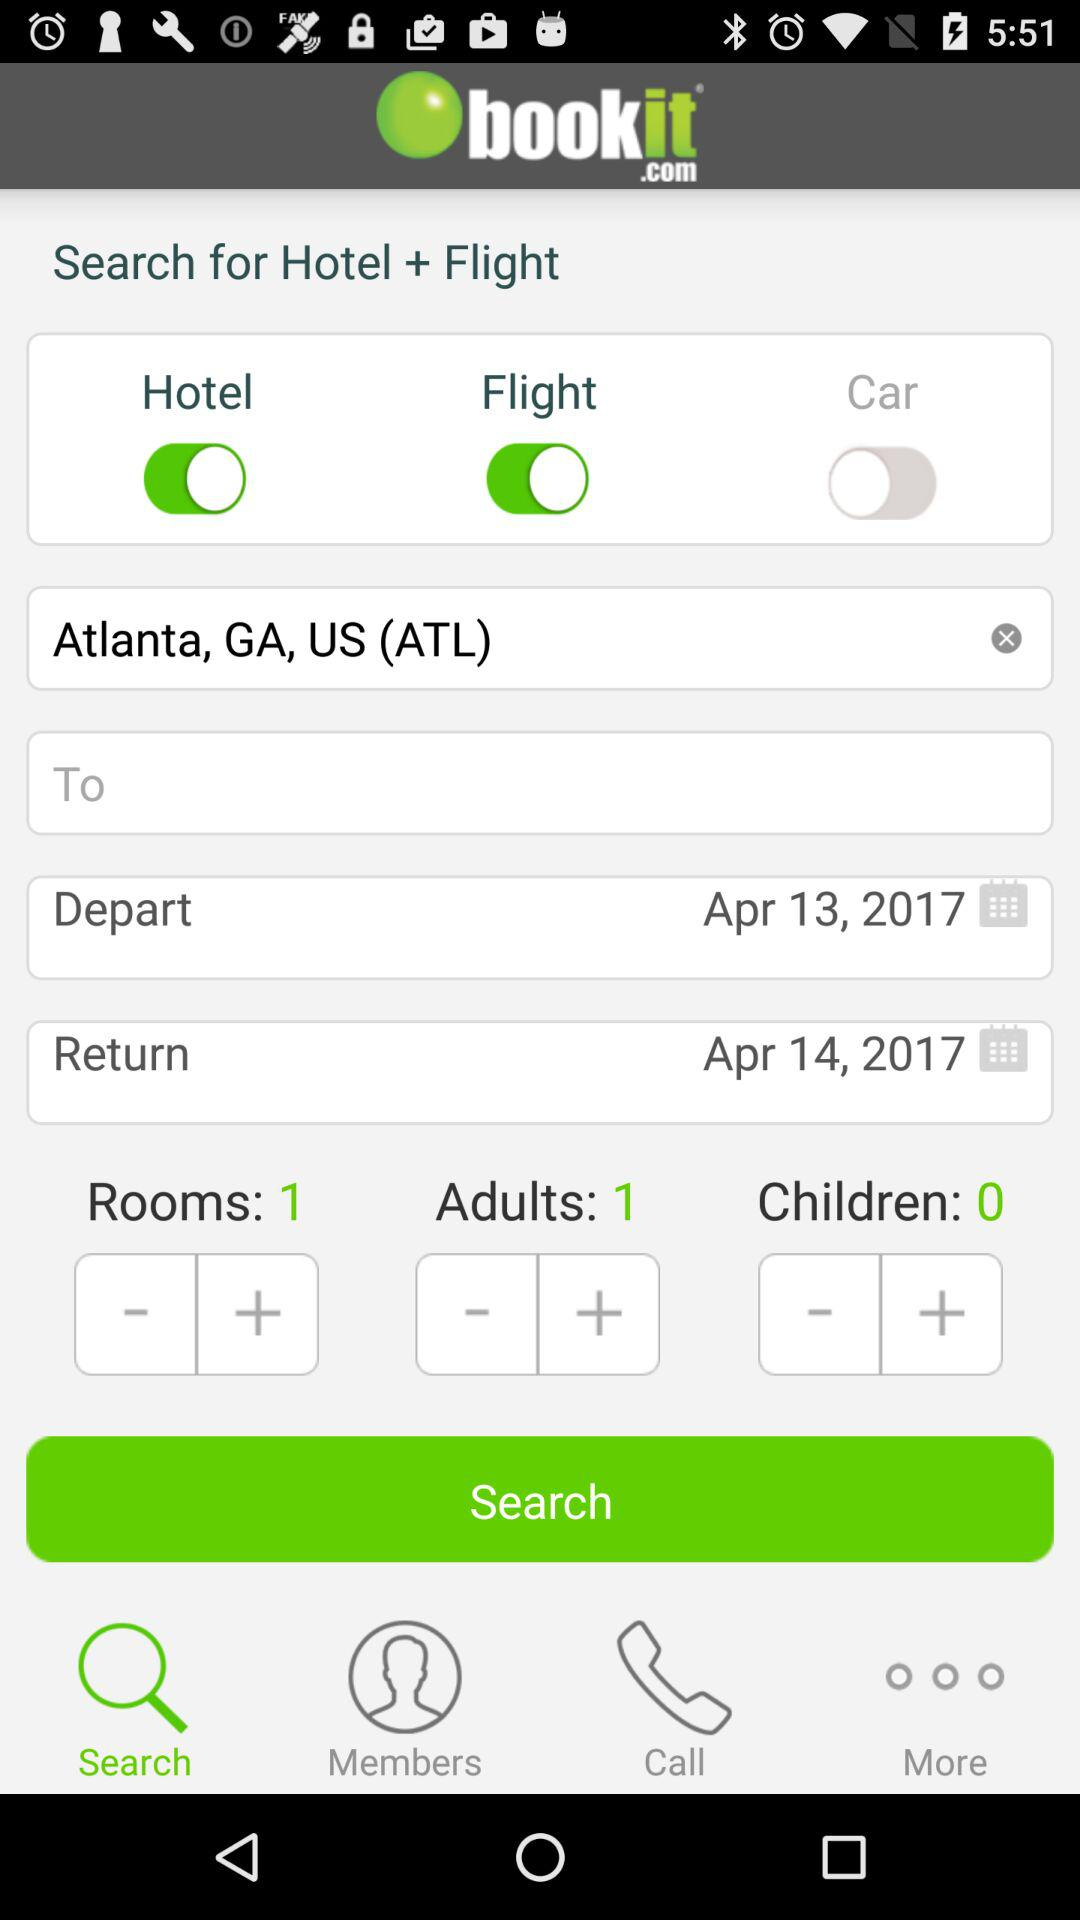What is the name of the application? The name of the application is "bookit.com". 